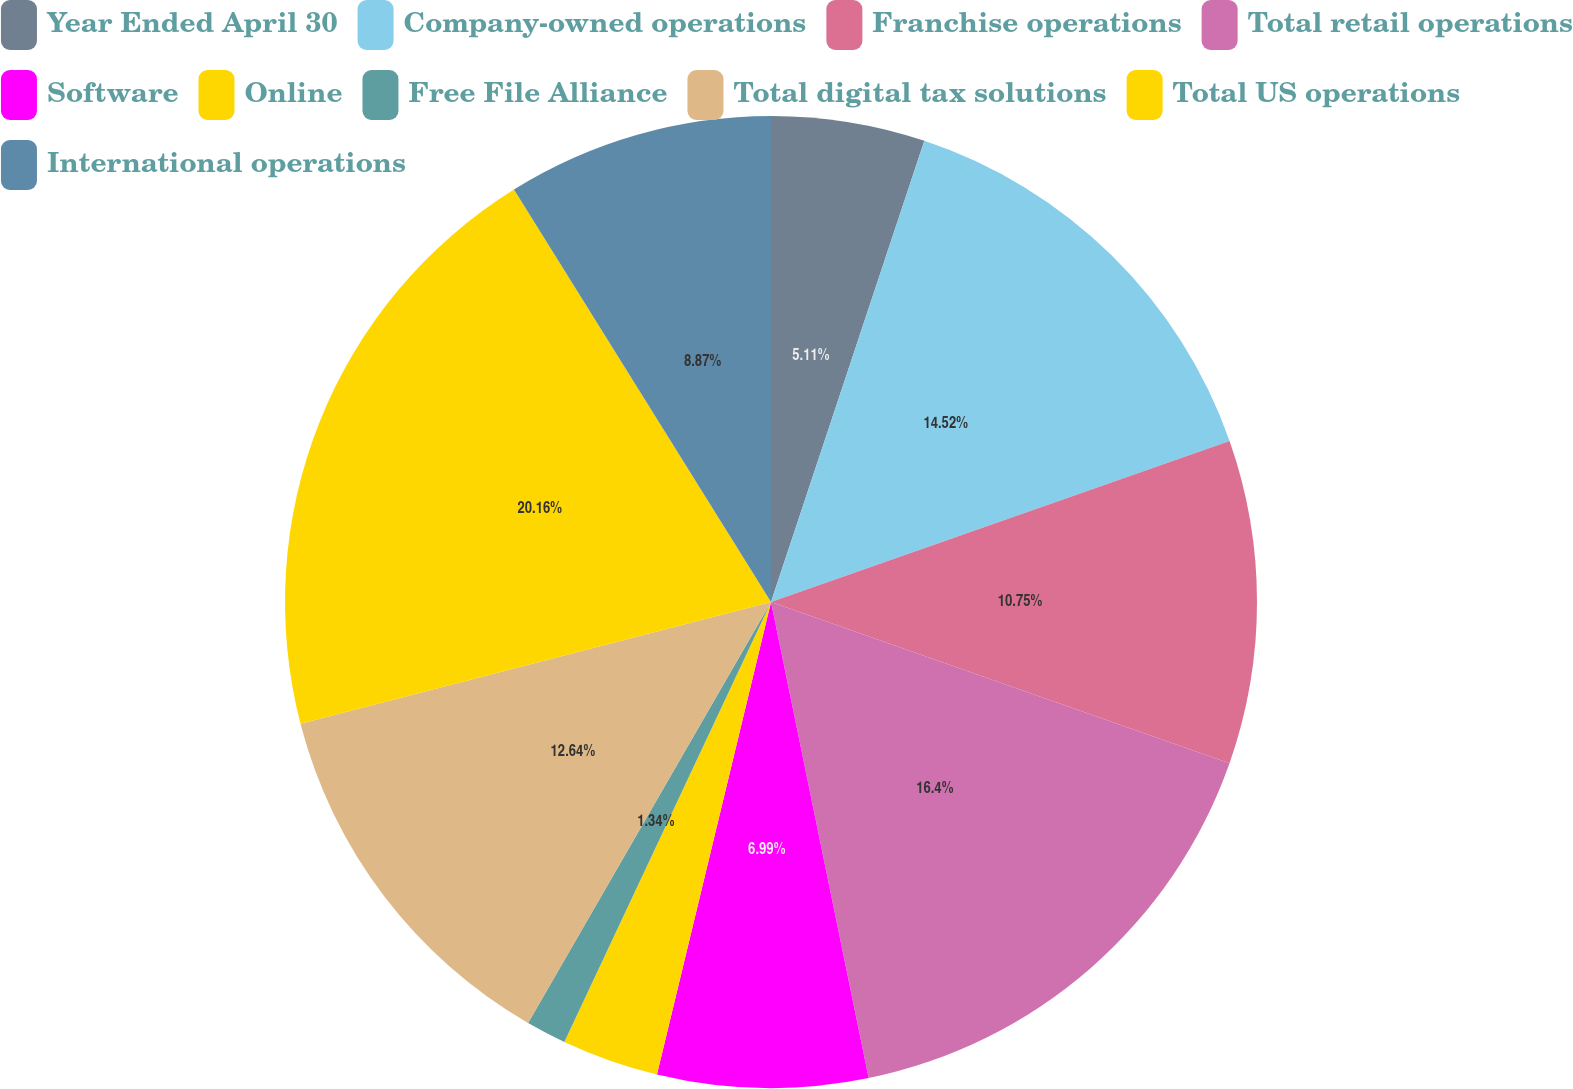Convert chart to OTSL. <chart><loc_0><loc_0><loc_500><loc_500><pie_chart><fcel>Year Ended April 30<fcel>Company-owned operations<fcel>Franchise operations<fcel>Total retail operations<fcel>Software<fcel>Online<fcel>Free File Alliance<fcel>Total digital tax solutions<fcel>Total US operations<fcel>International operations<nl><fcel>5.11%<fcel>14.52%<fcel>10.75%<fcel>16.4%<fcel>6.99%<fcel>3.22%<fcel>1.34%<fcel>12.64%<fcel>20.16%<fcel>8.87%<nl></chart> 